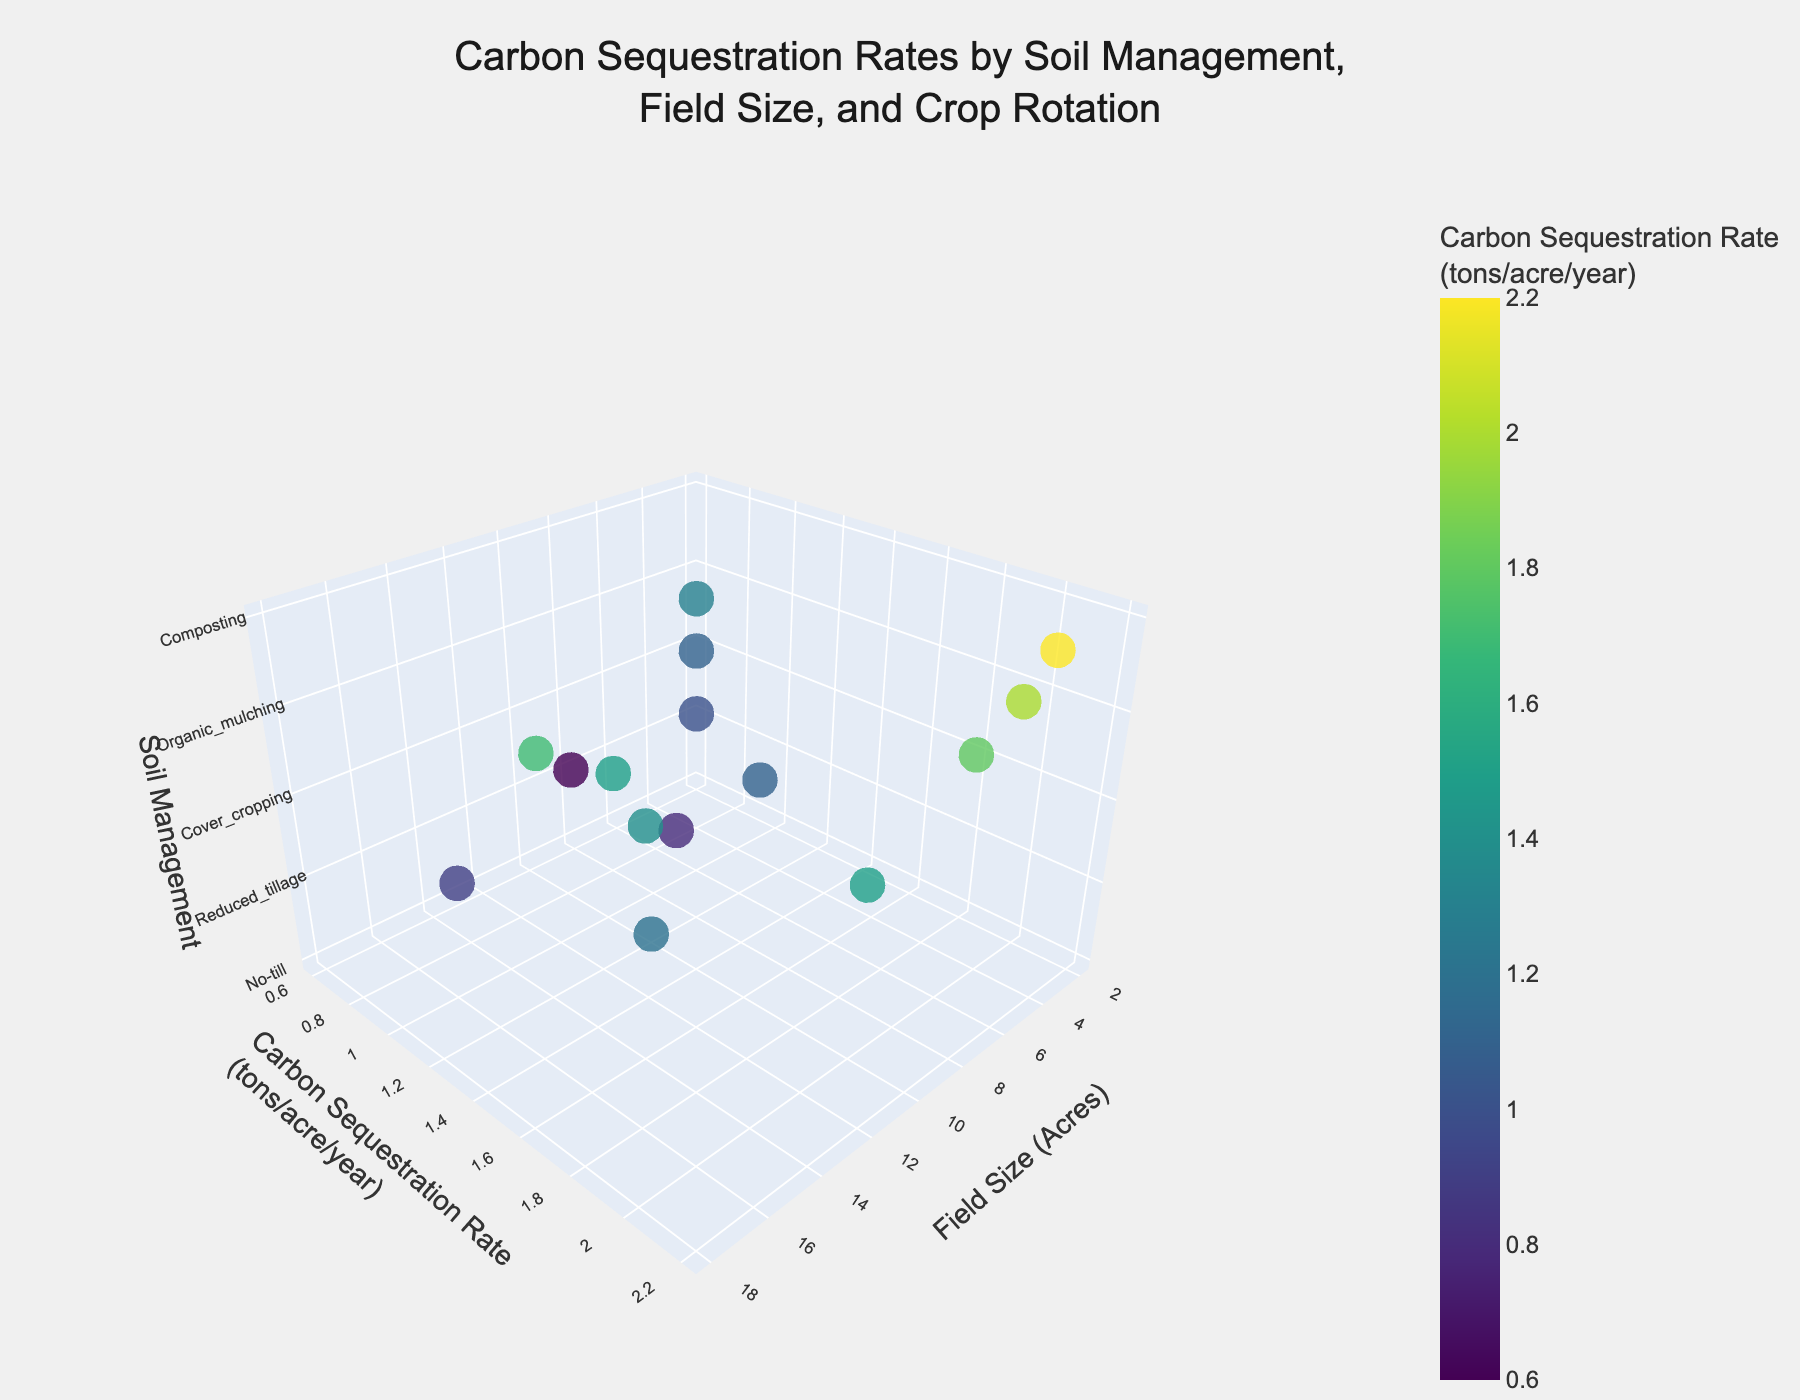How many types of soil management practices are depicted in the plot? There are 5 different types of soil management practices labeled on the z-axis: No-till, Reduced tillage, Cover cropping, Organic mulching, and Composting.
Answer: 5 What's the carbon sequestration rate for the cover cropping practice with vegetable-cover crop rotation on a 2-acre field? Locate the cover cropping category on the z-axis, then find the point with a field size of 2 acres. The corresponding y-axis value for carbon sequestration rate is 1.8 tons/acre/year.
Answer: 1.8 tons/acre/year Which soil management practice has the highest carbon sequestration rate? The highest point on the y-axis under carbon sequestration corresponds to the practice with the highest value, which is the composting practice in a vegetable-cover crop rotation.
Answer: Composting What is the field size for conventional tillage associated with the corn-soybean-wheat rotation with the lowest carbon sequestration rate? Find conventional tillage practices on the z-axis, identify points related to the corn-soybean-wheat rotation, and check their corresponding field sizes. The field size associated with the lowest rate (0.9 tons/acre/year) is 15 acres.
Answer: 15 acres What's the average carbon sequestration rate for fields managed by no-till practices? Look at all points labeled "No-till" on the z-axis and note their y-axis values: (0.8, 1.2, 1.5). Sum these values and divide by 3 to get the average: (0.8 + 1.2 + 1.5) / 3 = 1.17 tons/acre/year.
Answer: 1.17 tons/acre/year Compare the carbon sequestration rate between no-till and composting for vegetable-cover crop rotations. Which practice is more effective? Locate vegetable-cover crop rotations under both no-till and composting. For no-till, the rate is 1.5 tons/acre/year, and for composting, it is 2.2 tons/acre/year. Composting has a higher rate.
Answer: Composting Which crop rotation has the greatest variance in carbon sequestration rates across all soil management practices? Look at the variance among the carbon sequestration rates for each crop rotation across different soil management practices. The vegetable-cover crop rotation shows rates from 1.1 to 2.2, showing the greatest variability.
Answer: Vegetable-cover crop Is there a trend between field size and carbon sequestration rate for organic mulching practices? Observe points under "Organic mulching" on the z-axis and compare field sizes to their corresponding carbon sequestration rates. There is no clear trend as small fields (3 acres) have both the highest (2.0) and one of the lowest (1.1) rates.
Answer: No clear trend How does the carbon sequestration rate for corn-soybean-wheat rotations compare across different soil management practices? Check the points for corn-soybean-wheat rotations under each soil management practice: (No-till: 1.2, Reduced tillage: 0.9, Cover cropping: 1.4, Organic mulching: 1.5, Composting: 1.7). Composting has the highest rate, and reduced tillage has the lowest.
Answer: Composting > Organic mulching > Cover cropping > No-till > Reduced tillage Which soil management practice coupled with the corn-soybean rotation has the lowest carbon sequestration rate? Focus on corn-soybean rotations and their rates for different soil management practices (No-till: 0.8, Reduced tillage: 0.6, Cover cropping: 1.0, Organic mulching: 1.1, Composting: 1.3). Reduced tillage has the lowest rate.
Answer: Reduced tillage 